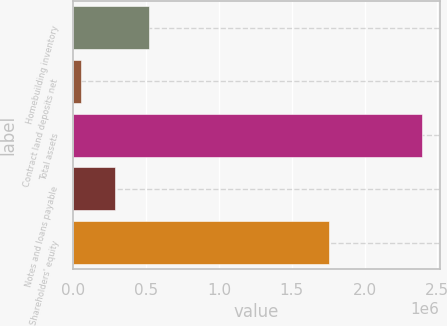Convert chart. <chart><loc_0><loc_0><loc_500><loc_500><bar_chart><fcel>Homebuilding inventory<fcel>Contract land deposits net<fcel>Total assets<fcel>Notes and loans payable<fcel>Shareholders' equity<nl><fcel>519079<fcel>49906<fcel>2.39577e+06<fcel>284492<fcel>1.75726e+06<nl></chart> 